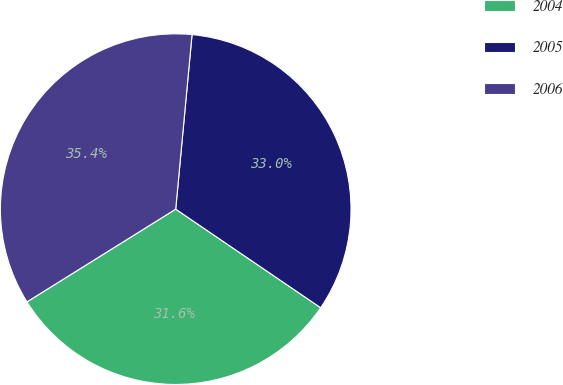<chart> <loc_0><loc_0><loc_500><loc_500><pie_chart><fcel>2004<fcel>2005<fcel>2006<nl><fcel>31.62%<fcel>33.02%<fcel>35.36%<nl></chart> 